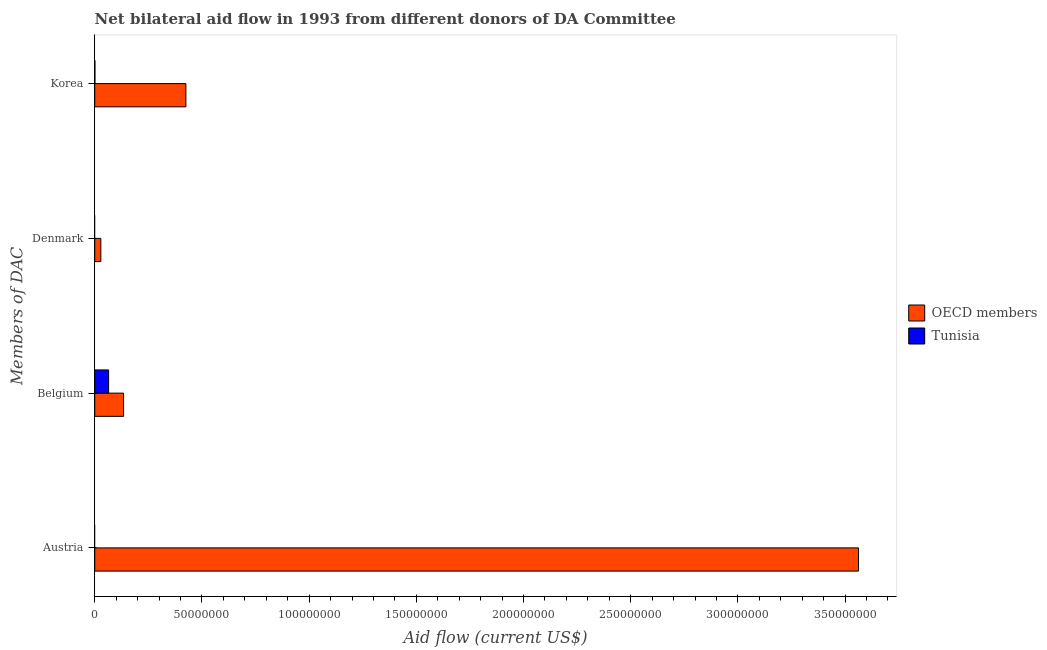How many different coloured bars are there?
Your answer should be very brief. 2. What is the amount of aid given by denmark in Tunisia?
Offer a terse response. 0. Across all countries, what is the maximum amount of aid given by denmark?
Offer a terse response. 2.84e+06. Across all countries, what is the minimum amount of aid given by belgium?
Provide a succinct answer. 6.47e+06. What is the total amount of aid given by korea in the graph?
Your answer should be compact. 4.26e+07. What is the difference between the amount of aid given by belgium in Tunisia and that in OECD members?
Give a very brief answer. -6.98e+06. What is the difference between the amount of aid given by korea in OECD members and the amount of aid given by belgium in Tunisia?
Your answer should be very brief. 3.60e+07. What is the average amount of aid given by denmark per country?
Give a very brief answer. 1.42e+06. What is the difference between the amount of aid given by belgium and amount of aid given by denmark in OECD members?
Your answer should be compact. 1.06e+07. In how many countries, is the amount of aid given by denmark greater than 50000000 US$?
Offer a terse response. 0. What is the ratio of the amount of aid given by korea in OECD members to that in Tunisia?
Provide a succinct answer. 531.5. What is the difference between the highest and the second highest amount of aid given by belgium?
Provide a short and direct response. 6.98e+06. What is the difference between the highest and the lowest amount of aid given by korea?
Your answer should be compact. 4.24e+07. Is the sum of the amount of aid given by korea in OECD members and Tunisia greater than the maximum amount of aid given by denmark across all countries?
Make the answer very short. Yes. Are all the bars in the graph horizontal?
Ensure brevity in your answer.  Yes. Are the values on the major ticks of X-axis written in scientific E-notation?
Your response must be concise. No. Does the graph contain any zero values?
Your response must be concise. Yes. Where does the legend appear in the graph?
Ensure brevity in your answer.  Center right. How many legend labels are there?
Ensure brevity in your answer.  2. What is the title of the graph?
Make the answer very short. Net bilateral aid flow in 1993 from different donors of DA Committee. Does "St. Kitts and Nevis" appear as one of the legend labels in the graph?
Provide a short and direct response. No. What is the label or title of the X-axis?
Provide a short and direct response. Aid flow (current US$). What is the label or title of the Y-axis?
Provide a succinct answer. Members of DAC. What is the Aid flow (current US$) of OECD members in Austria?
Offer a very short reply. 3.56e+08. What is the Aid flow (current US$) in OECD members in Belgium?
Your answer should be very brief. 1.34e+07. What is the Aid flow (current US$) in Tunisia in Belgium?
Your answer should be compact. 6.47e+06. What is the Aid flow (current US$) of OECD members in Denmark?
Your answer should be very brief. 2.84e+06. What is the Aid flow (current US$) of Tunisia in Denmark?
Make the answer very short. 0. What is the Aid flow (current US$) in OECD members in Korea?
Your answer should be compact. 4.25e+07. Across all Members of DAC, what is the maximum Aid flow (current US$) of OECD members?
Your answer should be very brief. 3.56e+08. Across all Members of DAC, what is the maximum Aid flow (current US$) of Tunisia?
Make the answer very short. 6.47e+06. Across all Members of DAC, what is the minimum Aid flow (current US$) of OECD members?
Your response must be concise. 2.84e+06. What is the total Aid flow (current US$) of OECD members in the graph?
Ensure brevity in your answer.  4.15e+08. What is the total Aid flow (current US$) in Tunisia in the graph?
Make the answer very short. 6.55e+06. What is the difference between the Aid flow (current US$) in OECD members in Austria and that in Belgium?
Ensure brevity in your answer.  3.43e+08. What is the difference between the Aid flow (current US$) in OECD members in Austria and that in Denmark?
Your response must be concise. 3.53e+08. What is the difference between the Aid flow (current US$) of OECD members in Austria and that in Korea?
Provide a short and direct response. 3.14e+08. What is the difference between the Aid flow (current US$) in OECD members in Belgium and that in Denmark?
Provide a short and direct response. 1.06e+07. What is the difference between the Aid flow (current US$) of OECD members in Belgium and that in Korea?
Your answer should be compact. -2.91e+07. What is the difference between the Aid flow (current US$) of Tunisia in Belgium and that in Korea?
Your answer should be very brief. 6.39e+06. What is the difference between the Aid flow (current US$) of OECD members in Denmark and that in Korea?
Make the answer very short. -3.97e+07. What is the difference between the Aid flow (current US$) of OECD members in Austria and the Aid flow (current US$) of Tunisia in Belgium?
Your answer should be compact. 3.50e+08. What is the difference between the Aid flow (current US$) in OECD members in Austria and the Aid flow (current US$) in Tunisia in Korea?
Provide a succinct answer. 3.56e+08. What is the difference between the Aid flow (current US$) of OECD members in Belgium and the Aid flow (current US$) of Tunisia in Korea?
Make the answer very short. 1.34e+07. What is the difference between the Aid flow (current US$) in OECD members in Denmark and the Aid flow (current US$) in Tunisia in Korea?
Provide a succinct answer. 2.76e+06. What is the average Aid flow (current US$) in OECD members per Members of DAC?
Ensure brevity in your answer.  1.04e+08. What is the average Aid flow (current US$) in Tunisia per Members of DAC?
Give a very brief answer. 1.64e+06. What is the difference between the Aid flow (current US$) of OECD members and Aid flow (current US$) of Tunisia in Belgium?
Your response must be concise. 6.98e+06. What is the difference between the Aid flow (current US$) in OECD members and Aid flow (current US$) in Tunisia in Korea?
Your answer should be very brief. 4.24e+07. What is the ratio of the Aid flow (current US$) in OECD members in Austria to that in Belgium?
Give a very brief answer. 26.49. What is the ratio of the Aid flow (current US$) of OECD members in Austria to that in Denmark?
Keep it short and to the point. 125.44. What is the ratio of the Aid flow (current US$) of OECD members in Austria to that in Korea?
Offer a very short reply. 8.38. What is the ratio of the Aid flow (current US$) of OECD members in Belgium to that in Denmark?
Your response must be concise. 4.74. What is the ratio of the Aid flow (current US$) in OECD members in Belgium to that in Korea?
Make the answer very short. 0.32. What is the ratio of the Aid flow (current US$) in Tunisia in Belgium to that in Korea?
Make the answer very short. 80.88. What is the ratio of the Aid flow (current US$) of OECD members in Denmark to that in Korea?
Ensure brevity in your answer.  0.07. What is the difference between the highest and the second highest Aid flow (current US$) in OECD members?
Your response must be concise. 3.14e+08. What is the difference between the highest and the lowest Aid flow (current US$) in OECD members?
Your answer should be compact. 3.53e+08. What is the difference between the highest and the lowest Aid flow (current US$) of Tunisia?
Your answer should be compact. 6.47e+06. 